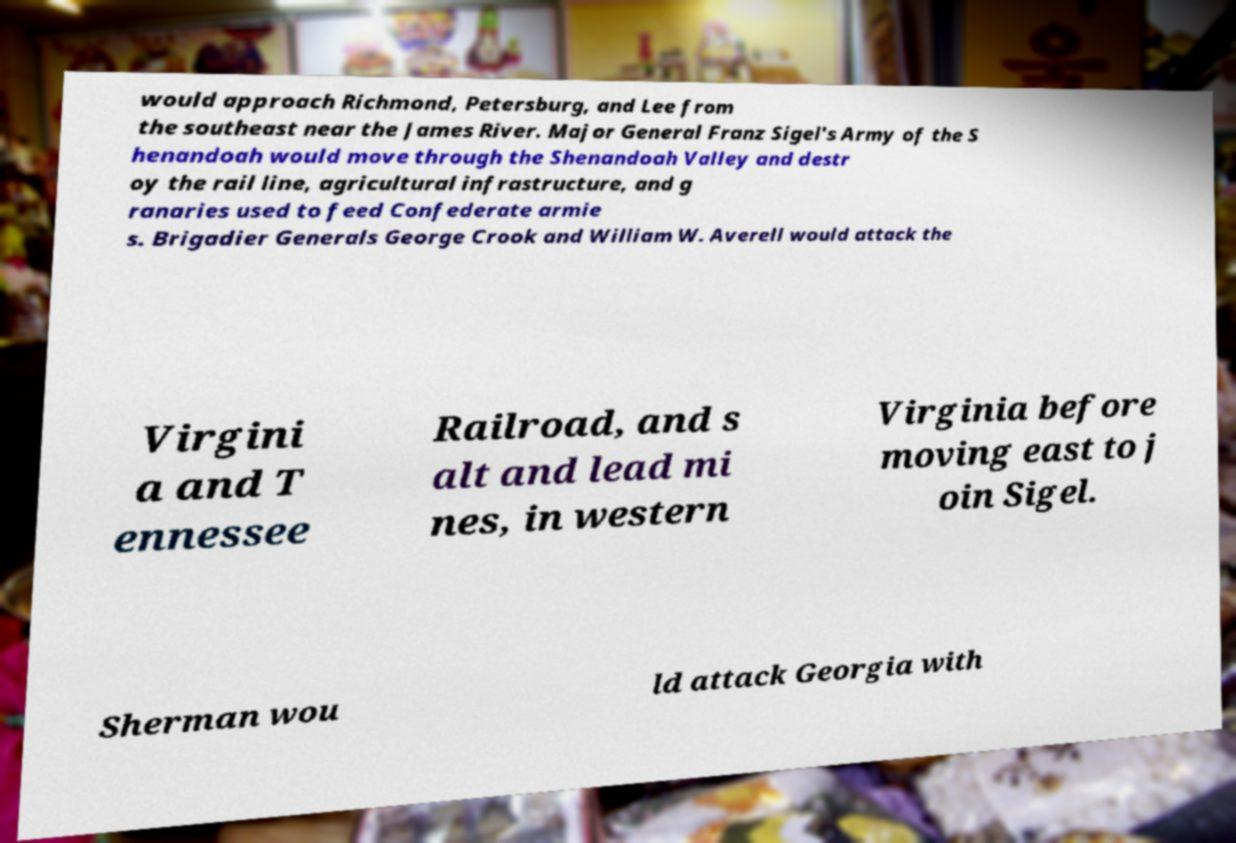There's text embedded in this image that I need extracted. Can you transcribe it verbatim? would approach Richmond, Petersburg, and Lee from the southeast near the James River. Major General Franz Sigel's Army of the S henandoah would move through the Shenandoah Valley and destr oy the rail line, agricultural infrastructure, and g ranaries used to feed Confederate armie s. Brigadier Generals George Crook and William W. Averell would attack the Virgini a and T ennessee Railroad, and s alt and lead mi nes, in western Virginia before moving east to j oin Sigel. Sherman wou ld attack Georgia with 